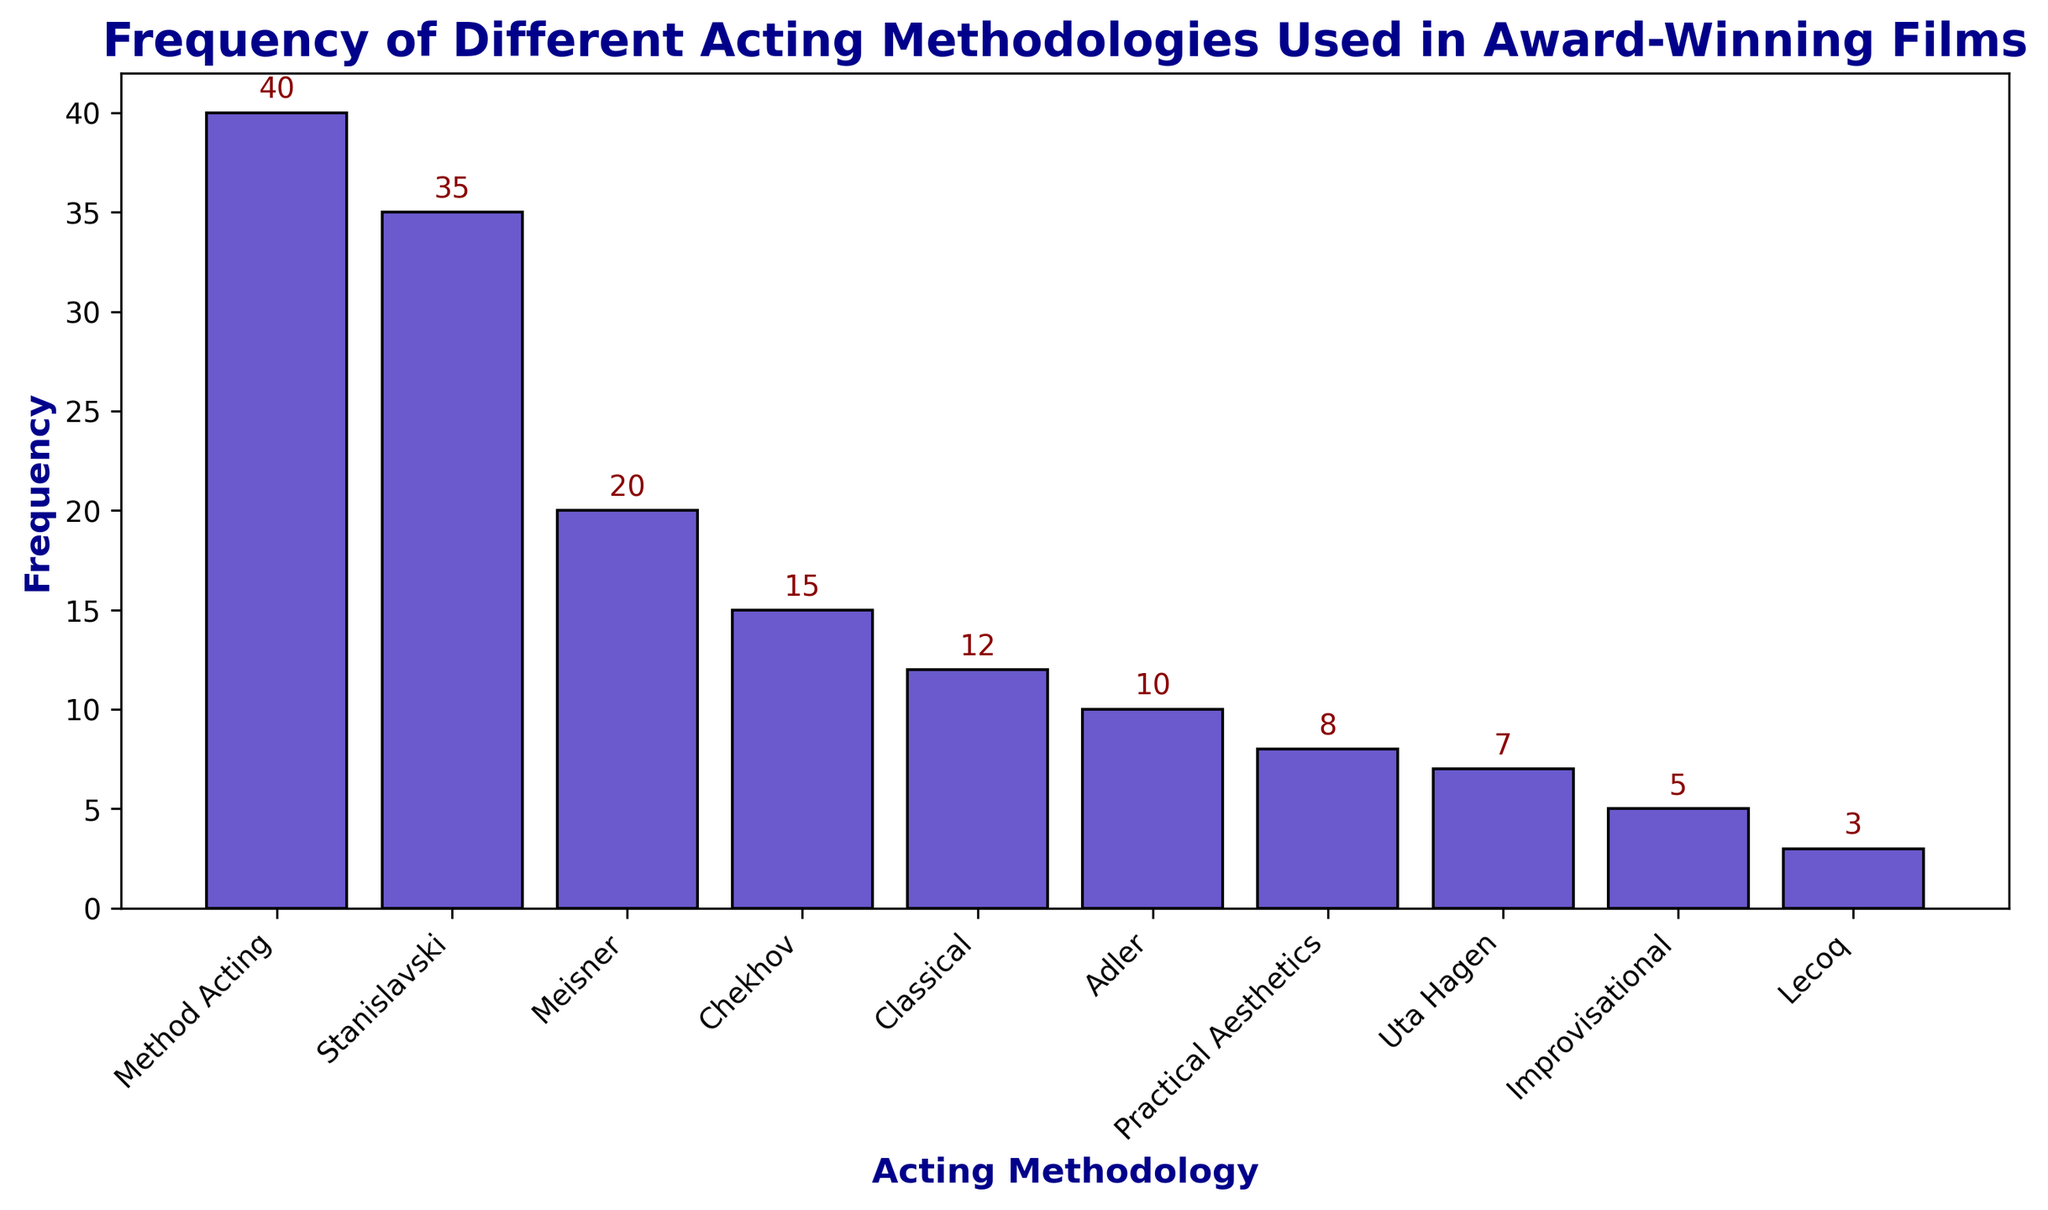Which acting methodology has the highest frequency? The bar with the tallest height represents the most frequent methodology. By examining the chart, we can see that Method Acting has the highest frequency.
Answer: Method Acting Which acting methodology has the lowest frequency? The bar with the shortest height represents the least frequent methodology. The chart shows that Lecoq has the lowest frequency.
Answer: Lecoq How many acting methodologies have a frequency greater than 15? Identify the bars with heights exceeding 15. The methodologies that meet this criterion are Stanislavski (35) and Method Acting (40). Hence, there are two methodologies with a frequency greater than 15.
Answer: 2 What is the total frequency of the methodologies that have a frequency between 5 and 20 inclusive? Identify the methodologies with frequencies between 5 and 20: Meisner (20), Chekhov (15), Adler (10), and Uta Hagen (7). Sum these frequencies: 20 + 15 + 10 + 7 = 52.
Answer: 52 What is the difference in frequency between Method Acting and Stanislavski? Find the frequencies of Method Acting (40) and Stanislavski (35). The difference between them is 40 - 35 = 5.
Answer: 5 Which methodology has a frequency that is exactly half of Stanislavski's frequency? Stanislavski’s frequency is 35. Half of 35 is 17.5. Upon checking the chart, none of the methodologies has a frequency of 17.5. Thus, there is no methodology with exactly half the frequency of Stanislavski.
Answer: None Compare the frequencies of Practical Aesthetics and Improvisational methodologies. Which one is higher? Practical Aesthetics has a frequency of 8, while Improvisational has a frequency of 5. Since 8 is greater than 5, Practical Aesthetics has a higher frequency.
Answer: Practical Aesthetics What is the combined frequency of the methodologies with the first and last ranks in frequency? The first rank (highest frequency) is Method Acting (40), and the last rank (lowest frequency) is Lecoq (3). Summing them: 40 + 3 = 43.
Answer: 43 What percentage of the total frequency does Method Acting represent? First, sum all the frequencies: 35 + 40 + 20 + 15 + 10 + 8 + 12 + 5 + 7 + 3 = 155. Next, calculate the percentage for Method Acting: (40/155) * 100 ≈ 25.81%.
Answer: 25.81% How does the frequency of Uta Hagen compare to the frequency of Lecoq and Improvisational combined? The frequency of Uta Hagen is 7. The combined frequency of Lecoq (3) and Improvisational (5) is 3 + 5 = 8. Since 7 is less than 8, Uta Hagen's frequency is lower.
Answer: Lower 